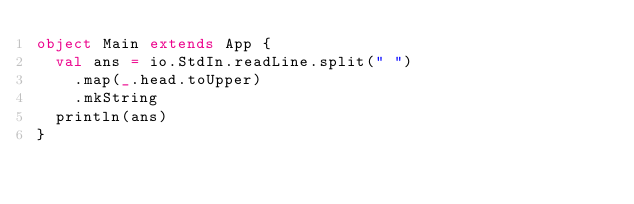<code> <loc_0><loc_0><loc_500><loc_500><_Scala_>object Main extends App {
  val ans = io.StdIn.readLine.split(" ")
    .map(_.head.toUpper)
    .mkString
  println(ans)
}</code> 